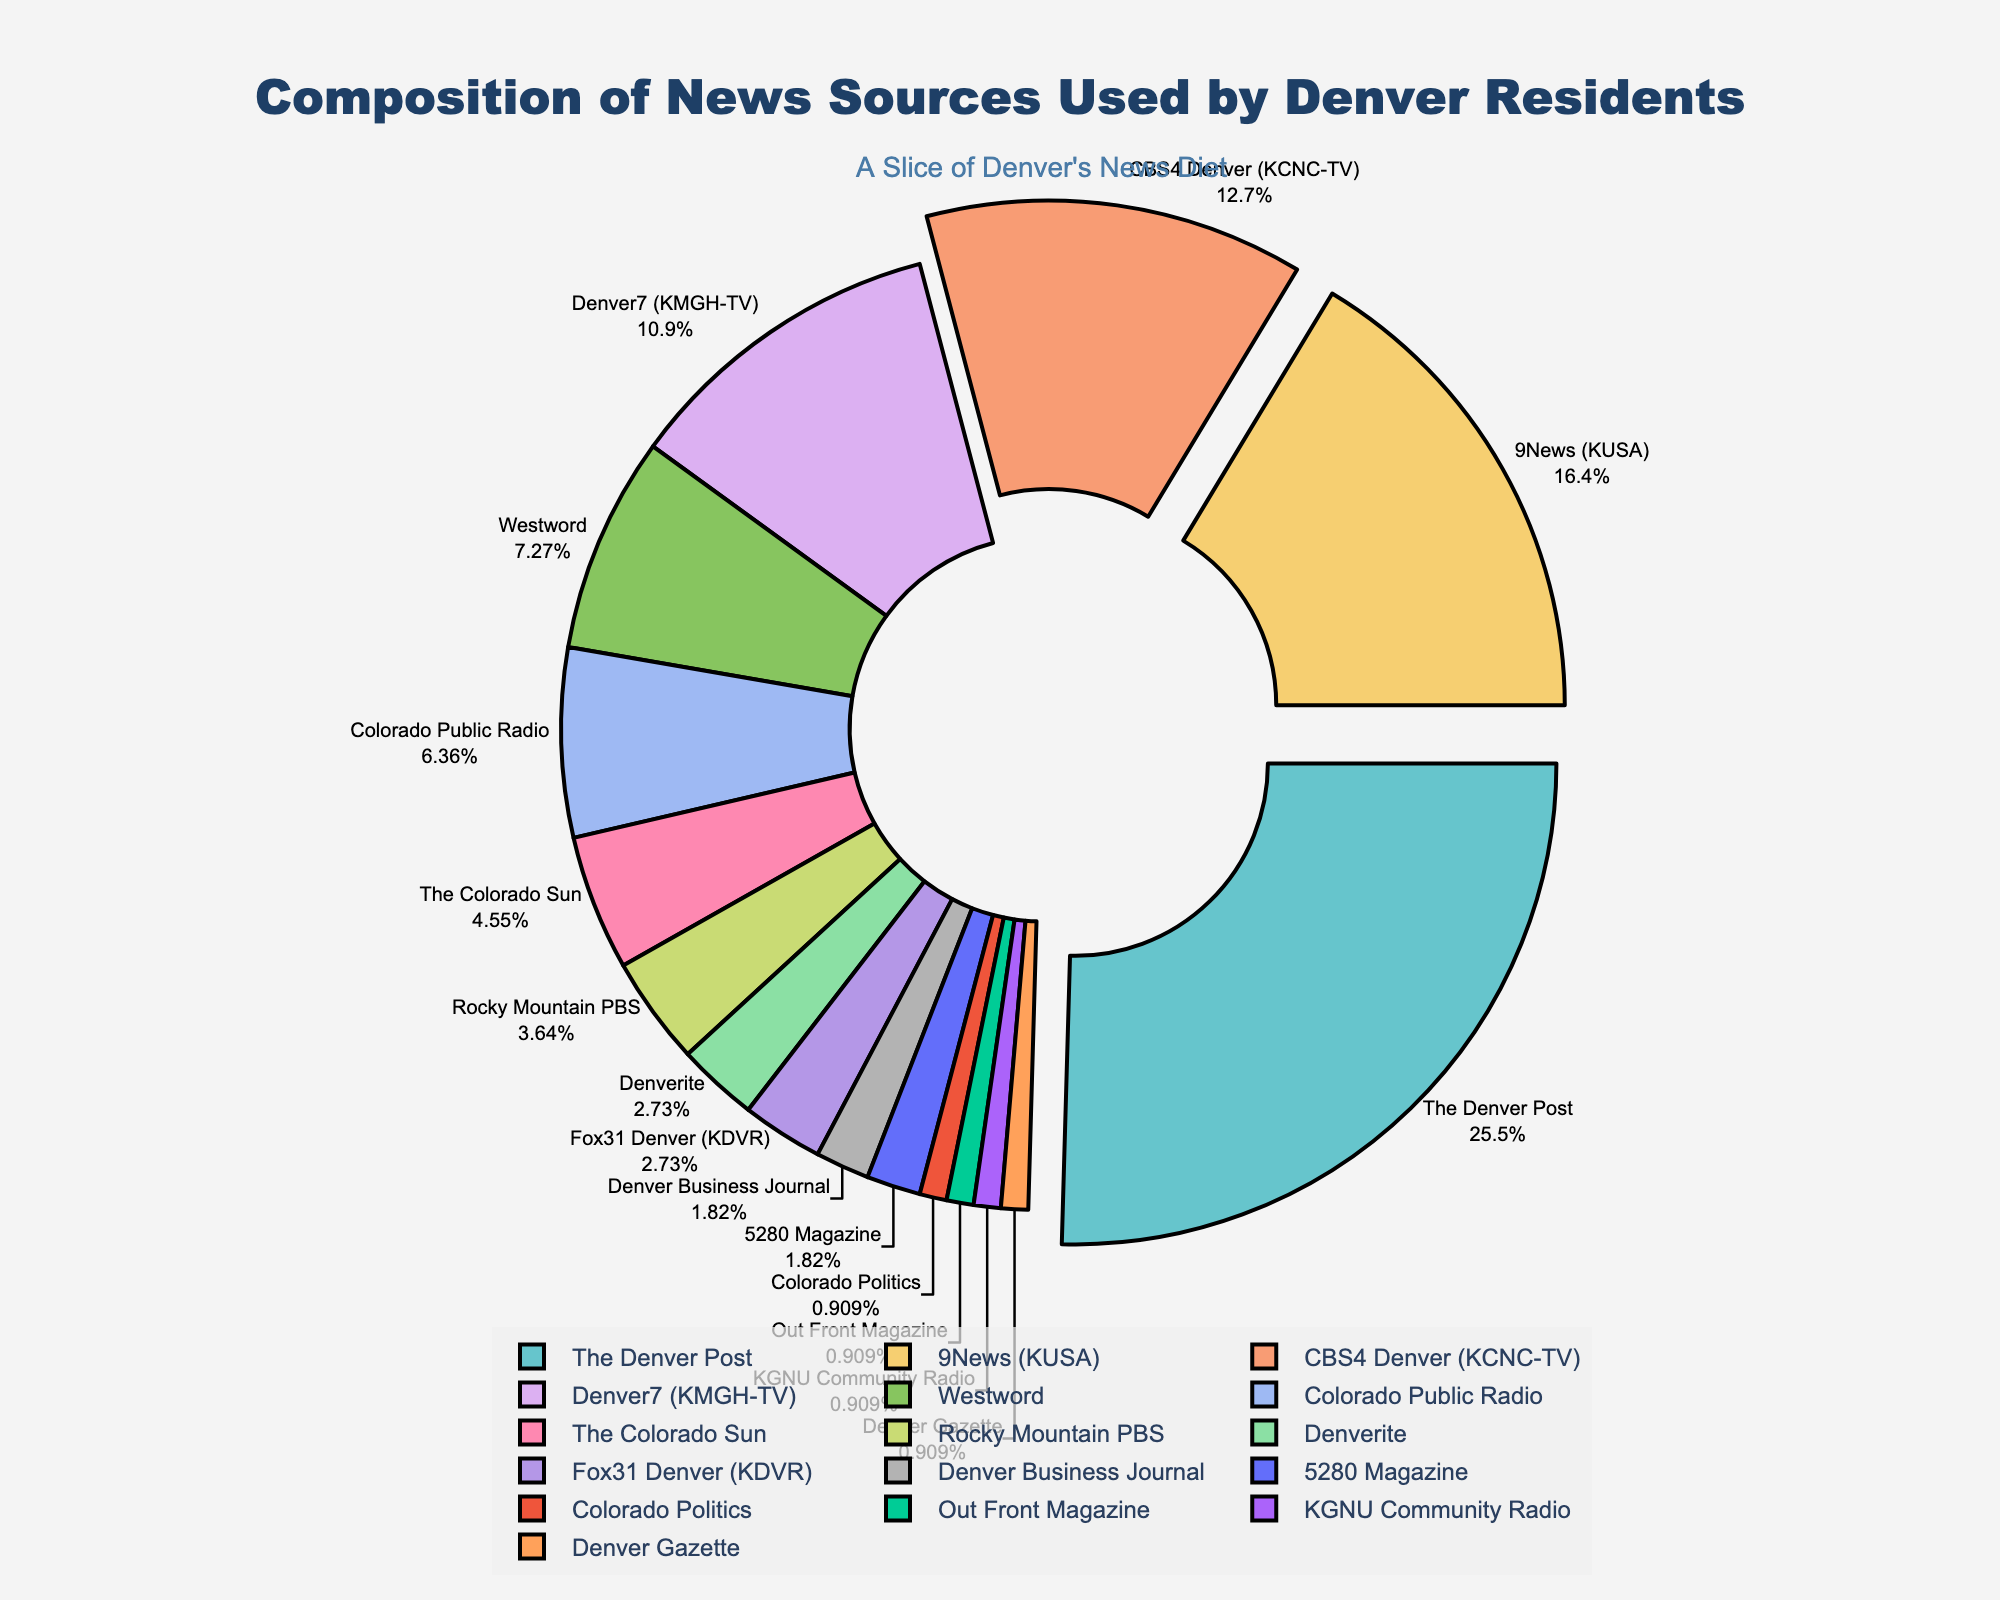What percentage of Denver residents use "The Denver Post" and "9News (KUSA)" combined as news sources? To find the combined percentage, add the percentages of "The Denver Post" and "9News (KUSA)". From the data, "The Denver Post" has 28% and "9News (KUSA)" has 18%. Therefore, the combined percentage is 28% + 18% = 46%.
Answer: 46% Which news source is used more by Denver residents: "Westword" or "Denver7 (KMGH-TV)"? "Denver7 (KMGH-TV)" is compared with "Westword". From the data, "Denver7 (KMGH-TV)" has 12%, while "Westword" has 8%. Therefore, "Denver7 (KMGH-TV)" is used more by Denver residents than "Westword".
Answer: "Denver7 (KMGH-TV)" Which news source is represented by the smallest slice in the pie chart? The smallest percentage in the data is 1%, which is shared by multiple sources. Hence, the smallest slice in the pie chart corresponds to the sources with 1% each: "Colorado Politics," "Out Front Magazine," "KGNU Community Radio," and "Denver Gazette".
Answer: "Colorado Politics, Out Front Magazine, KGNU Community Radio, Denver Gazette" What's the difference in the percentage points between "CBS4 Denver (KCNC-TV)" and "Fox31 Denver (KDVR)"? To find the difference, subtract the percentage of "Fox31 Denver (KDVR)" from "CBS4 Denver (KCNC-TV)". From the data, "CBS4 Denver (KCNC-TV)" has 14% and "Fox31 Denver (KDVR)" has 3%. Therefore, the difference is 14% - 3% = 11%.
Answer: 11% What is the average percentage of the news sources "Colorado Public Radio," "The Colorado Sun," and "Rocky Mountain PBS"? Calculate the average by summing the percentages of the three sources and dividing by 3. From the data, "Colorado Public Radio" has 7%, "The Colorado Sun" has 5%, and "Rocky Mountain PBS" has 4%. The sum is 7% + 5% + 4% = 16%. The average is 16% / 3 = 5.33%.
Answer: 5.33% How does the proportion of "5280 Magazine" compare to "Denverite"? Compare the percentages of the two sources. "5280 Magazine" has 2% and "Denverite" has 3%. Therefore, "Denverite" has a higher proportion than "5280 Magazine".
Answer: "Denverite" What fraction of the pie chart is represented by all the sources with less than 5% each? Identify the sources with less than 5% from the data: "The Colorado Sun" (5% not included), "Rocky Mountain PBS" (4%), "Denverite" (3%), "Fox31 Denver (KDVR)" (3%), "Denver Business Journal" (2%), "5280 Magazine" (2%), and those with 1% each. Sum their percentages: 4% + 3% + 3% + 2% + 2% + 4% = 19%.
Answer: 19% What is the most used news source among Denver residents? The most used news source is the one with the highest percentage. From the data, "The Denver Post" has the highest percentage at 28%.
Answer: "The Denver Post" If we sum the percentages of the three least-used news sources, what is the result? Identify and sum the percentages of the three least-used sources (each 1%): "Colorado Politics," "Out Front Magazine," "KGNU Community Radio," and "Denver Gazette". Sum three of these 1% sources: 1% + 1% + 1% = 3%.
Answer: 3% 